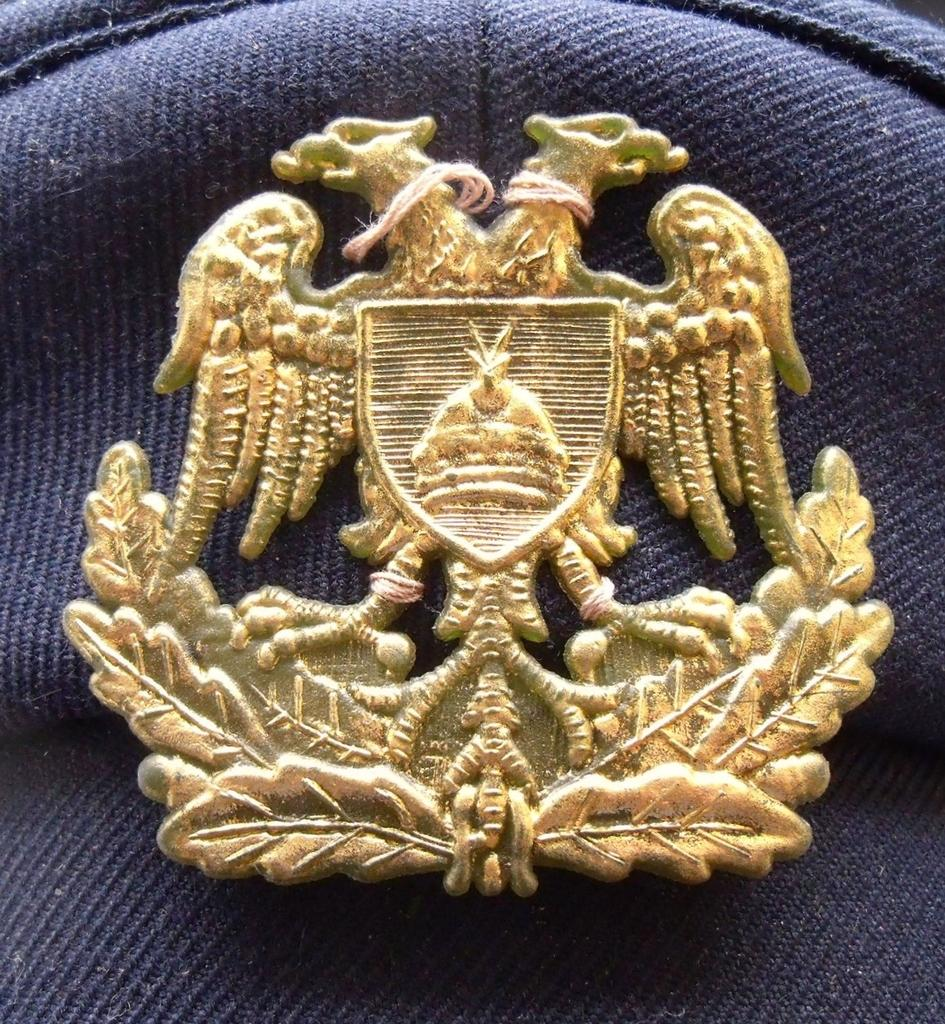What object is present in the image that might be used for identification or recognition? There is a badge in the image. What color is the cloth that the badge is placed on? The badge is on a blue cloth. What type of footwear is visible on the moon in the image? There is no moon or footwear present in the image; it only features a badge on a blue cloth. 